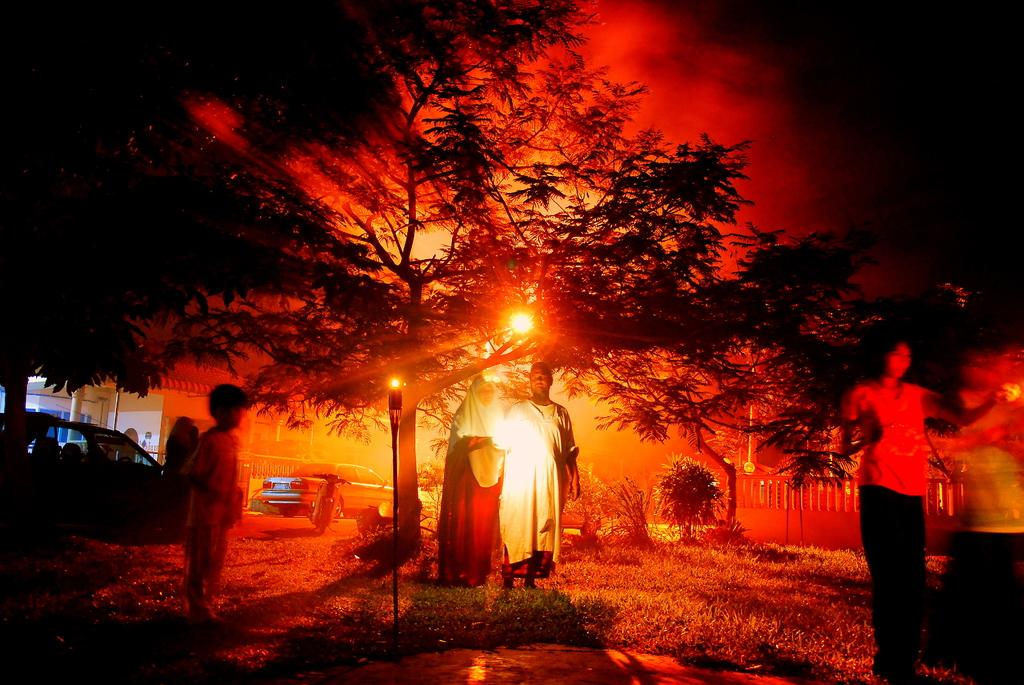How many people are present in the image? There are people in the image, but the exact number is not specified. What type of lighting is present in the image? There are lights in the image. What structure can be seen in the image? There is a pole in the image. What type of architectural feature is present in the image? There is railing in the image. What type of natural environment is visible in the image? There is grass, plants, and a tree in the image. What type of man-made structures are present in the image? There are vehicles and a building in the image. What is the condition of the sky in the image? The sky is dark in the image. What type of music is being played by the band in the image? There is no band present in the image. What time of day is it in the image? The time of day is not specified in the image, but the sky is dark, which could suggest nighttime or early morning. 